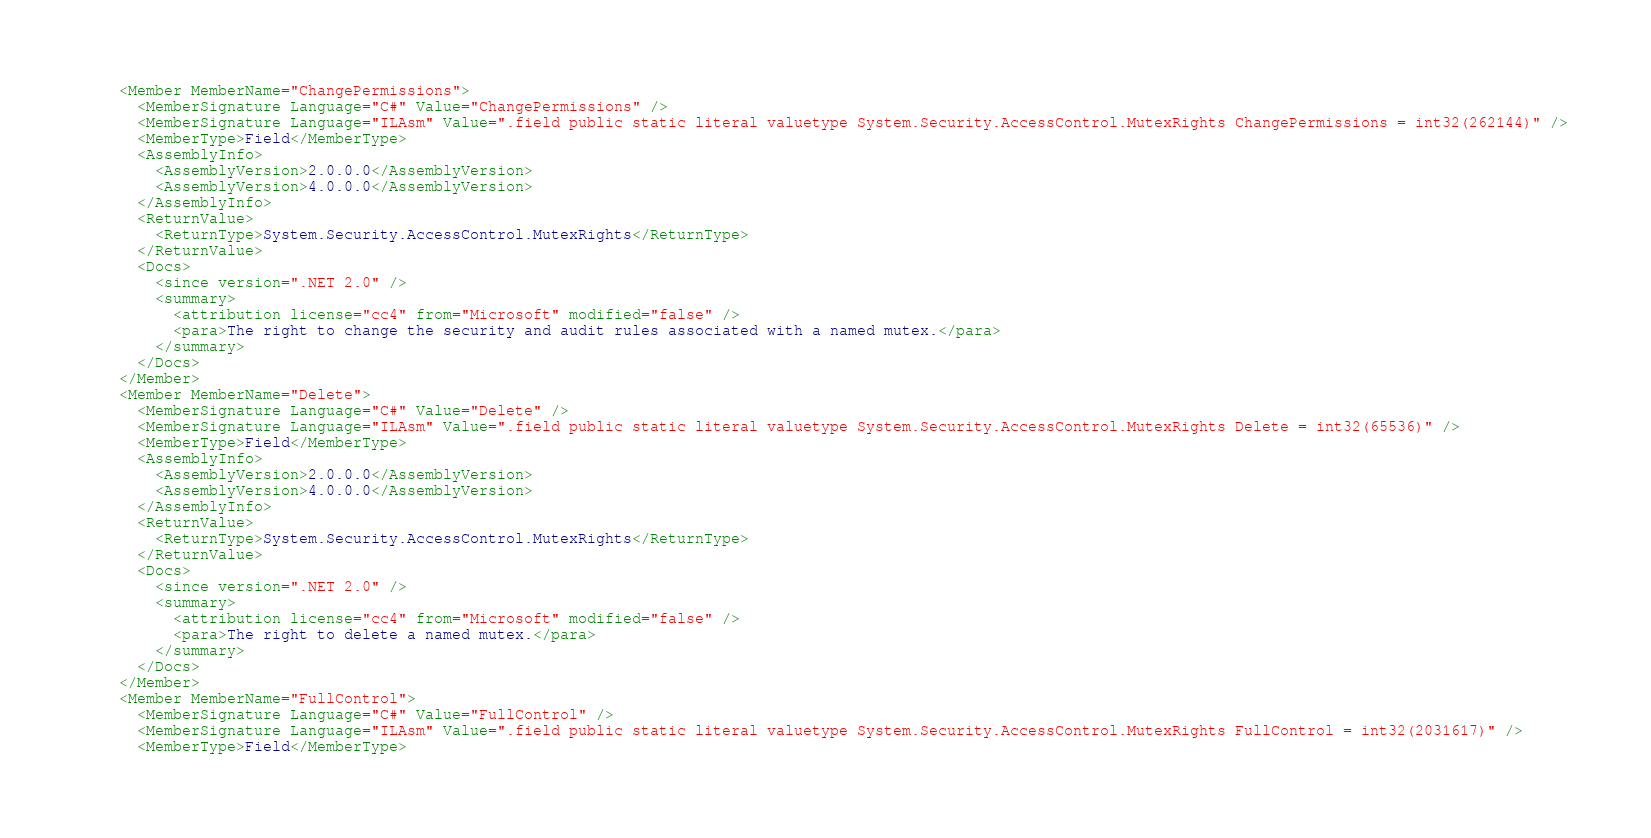Convert code to text. <code><loc_0><loc_0><loc_500><loc_500><_XML_>    <Member MemberName="ChangePermissions">
      <MemberSignature Language="C#" Value="ChangePermissions" />
      <MemberSignature Language="ILAsm" Value=".field public static literal valuetype System.Security.AccessControl.MutexRights ChangePermissions = int32(262144)" />
      <MemberType>Field</MemberType>
      <AssemblyInfo>
        <AssemblyVersion>2.0.0.0</AssemblyVersion>
        <AssemblyVersion>4.0.0.0</AssemblyVersion>
      </AssemblyInfo>
      <ReturnValue>
        <ReturnType>System.Security.AccessControl.MutexRights</ReturnType>
      </ReturnValue>
      <Docs>
        <since version=".NET 2.0" />
        <summary>
          <attribution license="cc4" from="Microsoft" modified="false" />
          <para>The right to change the security and audit rules associated with a named mutex.</para>
        </summary>
      </Docs>
    </Member>
    <Member MemberName="Delete">
      <MemberSignature Language="C#" Value="Delete" />
      <MemberSignature Language="ILAsm" Value=".field public static literal valuetype System.Security.AccessControl.MutexRights Delete = int32(65536)" />
      <MemberType>Field</MemberType>
      <AssemblyInfo>
        <AssemblyVersion>2.0.0.0</AssemblyVersion>
        <AssemblyVersion>4.0.0.0</AssemblyVersion>
      </AssemblyInfo>
      <ReturnValue>
        <ReturnType>System.Security.AccessControl.MutexRights</ReturnType>
      </ReturnValue>
      <Docs>
        <since version=".NET 2.0" />
        <summary>
          <attribution license="cc4" from="Microsoft" modified="false" />
          <para>The right to delete a named mutex.</para>
        </summary>
      </Docs>
    </Member>
    <Member MemberName="FullControl">
      <MemberSignature Language="C#" Value="FullControl" />
      <MemberSignature Language="ILAsm" Value=".field public static literal valuetype System.Security.AccessControl.MutexRights FullControl = int32(2031617)" />
      <MemberType>Field</MemberType></code> 